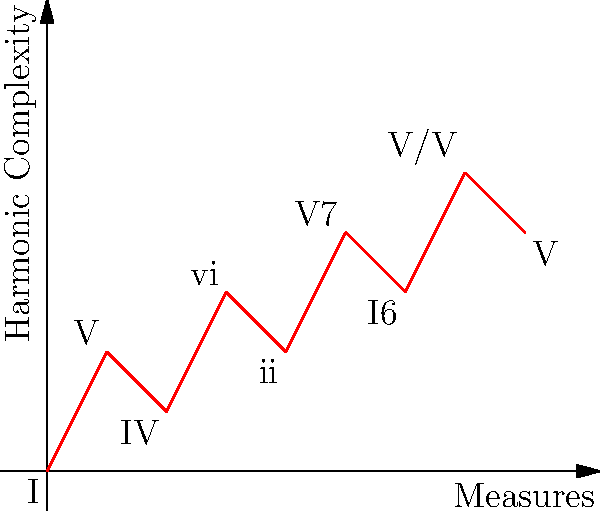Given the harmonic progression of the first movement of Tchaikovsky's Symphony No. 6 in B minor, "Pathétique," represented in the graph above, determine the vector that represents the harmonic motion from the initial tonic (I) to the secondary dominant (V/V) in measure 7. Express your answer in the form $(a,b)$, where $a$ represents the number of measures and $b$ represents the change in harmonic complexity. To solve this problem, we need to follow these steps:

1. Identify the starting point: The initial tonic (I) is at (0,0).
2. Identify the endpoint: The secondary dominant (V/V) is at (7,5).
3. Calculate the vector components:
   a. Horizontal component (measures): 7 - 0 = 7
   b. Vertical component (harmonic complexity): 5 - 0 = 5
4. Express the vector in the form (a,b):
   Vector = (7,5)

This vector represents the harmonic motion from the initial tonic to the secondary dominant, spanning 7 measures and increasing the harmonic complexity by 5 units.

In musicological terms, this vector captures the gradual increase in harmonic tension throughout the first part of the movement, typical of Tchaikovsky's dramatic style. The progression from I to V/V represents a significant build-up in harmonic complexity, setting up for a powerful resolution or further development in the symphony.
Answer: $(7,5)$ 